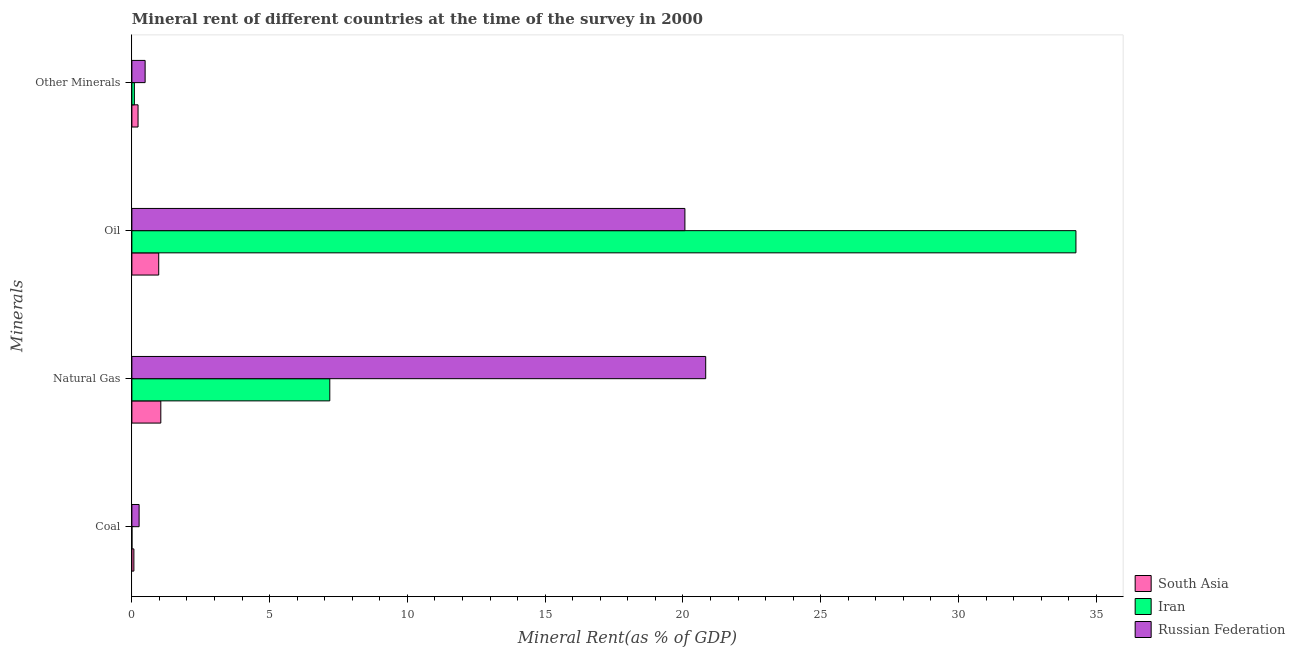How many groups of bars are there?
Your answer should be compact. 4. Are the number of bars per tick equal to the number of legend labels?
Ensure brevity in your answer.  Yes. How many bars are there on the 2nd tick from the bottom?
Offer a terse response. 3. What is the label of the 4th group of bars from the top?
Your answer should be very brief. Coal. What is the natural gas rent in South Asia?
Your answer should be very brief. 1.05. Across all countries, what is the maximum oil rent?
Ensure brevity in your answer.  34.26. Across all countries, what is the minimum natural gas rent?
Your answer should be very brief. 1.05. In which country was the oil rent maximum?
Offer a terse response. Iran. What is the total  rent of other minerals in the graph?
Your response must be concise. 0.8. What is the difference between the oil rent in Iran and that in Russian Federation?
Offer a terse response. 14.19. What is the difference between the oil rent in Iran and the natural gas rent in Russian Federation?
Provide a short and direct response. 13.44. What is the average natural gas rent per country?
Your answer should be compact. 9.69. What is the difference between the natural gas rent and  rent of other minerals in Russian Federation?
Keep it short and to the point. 20.34. In how many countries, is the natural gas rent greater than 25 %?
Offer a terse response. 0. What is the ratio of the natural gas rent in Russian Federation to that in South Asia?
Give a very brief answer. 19.83. Is the oil rent in Iran less than that in South Asia?
Ensure brevity in your answer.  No. What is the difference between the highest and the second highest natural gas rent?
Give a very brief answer. 13.64. What is the difference between the highest and the lowest oil rent?
Provide a succinct answer. 33.29. Is the sum of the  rent of other minerals in South Asia and Russian Federation greater than the maximum coal rent across all countries?
Provide a succinct answer. Yes. Is it the case that in every country, the sum of the coal rent and oil rent is greater than the sum of natural gas rent and  rent of other minerals?
Provide a short and direct response. Yes. What does the 1st bar from the top in Oil represents?
Your answer should be compact. Russian Federation. What does the 3rd bar from the bottom in Natural Gas represents?
Your answer should be compact. Russian Federation. Is it the case that in every country, the sum of the coal rent and natural gas rent is greater than the oil rent?
Provide a short and direct response. No. How many bars are there?
Offer a very short reply. 12. Are all the bars in the graph horizontal?
Offer a terse response. Yes. What is the difference between two consecutive major ticks on the X-axis?
Your answer should be very brief. 5. Are the values on the major ticks of X-axis written in scientific E-notation?
Provide a short and direct response. No. Does the graph contain any zero values?
Keep it short and to the point. No. Does the graph contain grids?
Your answer should be very brief. No. How many legend labels are there?
Keep it short and to the point. 3. What is the title of the graph?
Your answer should be compact. Mineral rent of different countries at the time of the survey in 2000. Does "St. Vincent and the Grenadines" appear as one of the legend labels in the graph?
Make the answer very short. No. What is the label or title of the X-axis?
Make the answer very short. Mineral Rent(as % of GDP). What is the label or title of the Y-axis?
Give a very brief answer. Minerals. What is the Mineral Rent(as % of GDP) of South Asia in Coal?
Offer a terse response. 0.07. What is the Mineral Rent(as % of GDP) of Iran in Coal?
Offer a very short reply. 0. What is the Mineral Rent(as % of GDP) of Russian Federation in Coal?
Provide a short and direct response. 0.26. What is the Mineral Rent(as % of GDP) in South Asia in Natural Gas?
Offer a terse response. 1.05. What is the Mineral Rent(as % of GDP) in Iran in Natural Gas?
Make the answer very short. 7.18. What is the Mineral Rent(as % of GDP) in Russian Federation in Natural Gas?
Provide a succinct answer. 20.83. What is the Mineral Rent(as % of GDP) of South Asia in Oil?
Offer a very short reply. 0.97. What is the Mineral Rent(as % of GDP) of Iran in Oil?
Give a very brief answer. 34.26. What is the Mineral Rent(as % of GDP) in Russian Federation in Oil?
Keep it short and to the point. 20.07. What is the Mineral Rent(as % of GDP) of South Asia in Other Minerals?
Your answer should be very brief. 0.22. What is the Mineral Rent(as % of GDP) of Iran in Other Minerals?
Offer a very short reply. 0.09. What is the Mineral Rent(as % of GDP) of Russian Federation in Other Minerals?
Ensure brevity in your answer.  0.48. Across all Minerals, what is the maximum Mineral Rent(as % of GDP) of South Asia?
Provide a short and direct response. 1.05. Across all Minerals, what is the maximum Mineral Rent(as % of GDP) of Iran?
Make the answer very short. 34.26. Across all Minerals, what is the maximum Mineral Rent(as % of GDP) of Russian Federation?
Offer a very short reply. 20.83. Across all Minerals, what is the minimum Mineral Rent(as % of GDP) of South Asia?
Keep it short and to the point. 0.07. Across all Minerals, what is the minimum Mineral Rent(as % of GDP) of Iran?
Offer a terse response. 0. Across all Minerals, what is the minimum Mineral Rent(as % of GDP) in Russian Federation?
Offer a very short reply. 0.26. What is the total Mineral Rent(as % of GDP) in South Asia in the graph?
Make the answer very short. 2.32. What is the total Mineral Rent(as % of GDP) in Iran in the graph?
Make the answer very short. 41.54. What is the total Mineral Rent(as % of GDP) of Russian Federation in the graph?
Your response must be concise. 41.64. What is the difference between the Mineral Rent(as % of GDP) of South Asia in Coal and that in Natural Gas?
Give a very brief answer. -0.98. What is the difference between the Mineral Rent(as % of GDP) in Iran in Coal and that in Natural Gas?
Provide a succinct answer. -7.18. What is the difference between the Mineral Rent(as % of GDP) in Russian Federation in Coal and that in Natural Gas?
Offer a terse response. -20.56. What is the difference between the Mineral Rent(as % of GDP) of South Asia in Coal and that in Oil?
Your answer should be compact. -0.9. What is the difference between the Mineral Rent(as % of GDP) of Iran in Coal and that in Oil?
Make the answer very short. -34.26. What is the difference between the Mineral Rent(as % of GDP) of Russian Federation in Coal and that in Oil?
Ensure brevity in your answer.  -19.81. What is the difference between the Mineral Rent(as % of GDP) of South Asia in Coal and that in Other Minerals?
Your response must be concise. -0.15. What is the difference between the Mineral Rent(as % of GDP) in Iran in Coal and that in Other Minerals?
Make the answer very short. -0.09. What is the difference between the Mineral Rent(as % of GDP) of Russian Federation in Coal and that in Other Minerals?
Give a very brief answer. -0.22. What is the difference between the Mineral Rent(as % of GDP) in South Asia in Natural Gas and that in Oil?
Your response must be concise. 0.08. What is the difference between the Mineral Rent(as % of GDP) of Iran in Natural Gas and that in Oil?
Offer a terse response. -27.08. What is the difference between the Mineral Rent(as % of GDP) in Russian Federation in Natural Gas and that in Oil?
Your answer should be compact. 0.75. What is the difference between the Mineral Rent(as % of GDP) in South Asia in Natural Gas and that in Other Minerals?
Your answer should be very brief. 0.83. What is the difference between the Mineral Rent(as % of GDP) of Iran in Natural Gas and that in Other Minerals?
Offer a very short reply. 7.09. What is the difference between the Mineral Rent(as % of GDP) of Russian Federation in Natural Gas and that in Other Minerals?
Offer a terse response. 20.34. What is the difference between the Mineral Rent(as % of GDP) in South Asia in Oil and that in Other Minerals?
Offer a very short reply. 0.75. What is the difference between the Mineral Rent(as % of GDP) of Iran in Oil and that in Other Minerals?
Your response must be concise. 34.17. What is the difference between the Mineral Rent(as % of GDP) of Russian Federation in Oil and that in Other Minerals?
Provide a succinct answer. 19.59. What is the difference between the Mineral Rent(as % of GDP) of South Asia in Coal and the Mineral Rent(as % of GDP) of Iran in Natural Gas?
Your answer should be compact. -7.11. What is the difference between the Mineral Rent(as % of GDP) of South Asia in Coal and the Mineral Rent(as % of GDP) of Russian Federation in Natural Gas?
Offer a terse response. -20.75. What is the difference between the Mineral Rent(as % of GDP) of Iran in Coal and the Mineral Rent(as % of GDP) of Russian Federation in Natural Gas?
Provide a short and direct response. -20.82. What is the difference between the Mineral Rent(as % of GDP) of South Asia in Coal and the Mineral Rent(as % of GDP) of Iran in Oil?
Provide a succinct answer. -34.19. What is the difference between the Mineral Rent(as % of GDP) of South Asia in Coal and the Mineral Rent(as % of GDP) of Russian Federation in Oil?
Keep it short and to the point. -20. What is the difference between the Mineral Rent(as % of GDP) in Iran in Coal and the Mineral Rent(as % of GDP) in Russian Federation in Oil?
Provide a succinct answer. -20.07. What is the difference between the Mineral Rent(as % of GDP) of South Asia in Coal and the Mineral Rent(as % of GDP) of Iran in Other Minerals?
Ensure brevity in your answer.  -0.02. What is the difference between the Mineral Rent(as % of GDP) in South Asia in Coal and the Mineral Rent(as % of GDP) in Russian Federation in Other Minerals?
Offer a very short reply. -0.41. What is the difference between the Mineral Rent(as % of GDP) of Iran in Coal and the Mineral Rent(as % of GDP) of Russian Federation in Other Minerals?
Keep it short and to the point. -0.48. What is the difference between the Mineral Rent(as % of GDP) of South Asia in Natural Gas and the Mineral Rent(as % of GDP) of Iran in Oil?
Ensure brevity in your answer.  -33.21. What is the difference between the Mineral Rent(as % of GDP) of South Asia in Natural Gas and the Mineral Rent(as % of GDP) of Russian Federation in Oil?
Make the answer very short. -19.02. What is the difference between the Mineral Rent(as % of GDP) in Iran in Natural Gas and the Mineral Rent(as % of GDP) in Russian Federation in Oil?
Provide a succinct answer. -12.89. What is the difference between the Mineral Rent(as % of GDP) in South Asia in Natural Gas and the Mineral Rent(as % of GDP) in Iran in Other Minerals?
Offer a very short reply. 0.96. What is the difference between the Mineral Rent(as % of GDP) of South Asia in Natural Gas and the Mineral Rent(as % of GDP) of Russian Federation in Other Minerals?
Your answer should be very brief. 0.57. What is the difference between the Mineral Rent(as % of GDP) of Iran in Natural Gas and the Mineral Rent(as % of GDP) of Russian Federation in Other Minerals?
Your response must be concise. 6.7. What is the difference between the Mineral Rent(as % of GDP) in South Asia in Oil and the Mineral Rent(as % of GDP) in Iran in Other Minerals?
Provide a short and direct response. 0.88. What is the difference between the Mineral Rent(as % of GDP) in South Asia in Oil and the Mineral Rent(as % of GDP) in Russian Federation in Other Minerals?
Provide a short and direct response. 0.49. What is the difference between the Mineral Rent(as % of GDP) of Iran in Oil and the Mineral Rent(as % of GDP) of Russian Federation in Other Minerals?
Ensure brevity in your answer.  33.78. What is the average Mineral Rent(as % of GDP) of South Asia per Minerals?
Provide a succinct answer. 0.58. What is the average Mineral Rent(as % of GDP) in Iran per Minerals?
Provide a short and direct response. 10.38. What is the average Mineral Rent(as % of GDP) in Russian Federation per Minerals?
Your answer should be very brief. 10.41. What is the difference between the Mineral Rent(as % of GDP) of South Asia and Mineral Rent(as % of GDP) of Iran in Coal?
Your answer should be compact. 0.07. What is the difference between the Mineral Rent(as % of GDP) in South Asia and Mineral Rent(as % of GDP) in Russian Federation in Coal?
Provide a succinct answer. -0.19. What is the difference between the Mineral Rent(as % of GDP) in Iran and Mineral Rent(as % of GDP) in Russian Federation in Coal?
Make the answer very short. -0.26. What is the difference between the Mineral Rent(as % of GDP) in South Asia and Mineral Rent(as % of GDP) in Iran in Natural Gas?
Your answer should be compact. -6.13. What is the difference between the Mineral Rent(as % of GDP) in South Asia and Mineral Rent(as % of GDP) in Russian Federation in Natural Gas?
Ensure brevity in your answer.  -19.78. What is the difference between the Mineral Rent(as % of GDP) of Iran and Mineral Rent(as % of GDP) of Russian Federation in Natural Gas?
Keep it short and to the point. -13.64. What is the difference between the Mineral Rent(as % of GDP) of South Asia and Mineral Rent(as % of GDP) of Iran in Oil?
Make the answer very short. -33.29. What is the difference between the Mineral Rent(as % of GDP) of South Asia and Mineral Rent(as % of GDP) of Russian Federation in Oil?
Keep it short and to the point. -19.1. What is the difference between the Mineral Rent(as % of GDP) in Iran and Mineral Rent(as % of GDP) in Russian Federation in Oil?
Provide a short and direct response. 14.19. What is the difference between the Mineral Rent(as % of GDP) of South Asia and Mineral Rent(as % of GDP) of Iran in Other Minerals?
Offer a very short reply. 0.13. What is the difference between the Mineral Rent(as % of GDP) of South Asia and Mineral Rent(as % of GDP) of Russian Federation in Other Minerals?
Give a very brief answer. -0.26. What is the difference between the Mineral Rent(as % of GDP) in Iran and Mineral Rent(as % of GDP) in Russian Federation in Other Minerals?
Give a very brief answer. -0.39. What is the ratio of the Mineral Rent(as % of GDP) of South Asia in Coal to that in Natural Gas?
Offer a very short reply. 0.07. What is the ratio of the Mineral Rent(as % of GDP) in Russian Federation in Coal to that in Natural Gas?
Your answer should be very brief. 0.01. What is the ratio of the Mineral Rent(as % of GDP) of South Asia in Coal to that in Oil?
Provide a short and direct response. 0.07. What is the ratio of the Mineral Rent(as % of GDP) in Iran in Coal to that in Oil?
Offer a terse response. 0. What is the ratio of the Mineral Rent(as % of GDP) in Russian Federation in Coal to that in Oil?
Keep it short and to the point. 0.01. What is the ratio of the Mineral Rent(as % of GDP) of South Asia in Coal to that in Other Minerals?
Your answer should be very brief. 0.33. What is the ratio of the Mineral Rent(as % of GDP) in Iran in Coal to that in Other Minerals?
Offer a terse response. 0.03. What is the ratio of the Mineral Rent(as % of GDP) in Russian Federation in Coal to that in Other Minerals?
Your answer should be very brief. 0.55. What is the ratio of the Mineral Rent(as % of GDP) of South Asia in Natural Gas to that in Oil?
Provide a short and direct response. 1.08. What is the ratio of the Mineral Rent(as % of GDP) in Iran in Natural Gas to that in Oil?
Ensure brevity in your answer.  0.21. What is the ratio of the Mineral Rent(as % of GDP) in Russian Federation in Natural Gas to that in Oil?
Keep it short and to the point. 1.04. What is the ratio of the Mineral Rent(as % of GDP) of South Asia in Natural Gas to that in Other Minerals?
Make the answer very short. 4.69. What is the ratio of the Mineral Rent(as % of GDP) of Iran in Natural Gas to that in Other Minerals?
Provide a short and direct response. 79.19. What is the ratio of the Mineral Rent(as % of GDP) in Russian Federation in Natural Gas to that in Other Minerals?
Make the answer very short. 43.3. What is the ratio of the Mineral Rent(as % of GDP) of South Asia in Oil to that in Other Minerals?
Ensure brevity in your answer.  4.35. What is the ratio of the Mineral Rent(as % of GDP) in Iran in Oil to that in Other Minerals?
Your answer should be compact. 377.72. What is the ratio of the Mineral Rent(as % of GDP) in Russian Federation in Oil to that in Other Minerals?
Your answer should be very brief. 41.73. What is the difference between the highest and the second highest Mineral Rent(as % of GDP) in South Asia?
Keep it short and to the point. 0.08. What is the difference between the highest and the second highest Mineral Rent(as % of GDP) in Iran?
Offer a terse response. 27.08. What is the difference between the highest and the second highest Mineral Rent(as % of GDP) of Russian Federation?
Provide a short and direct response. 0.75. What is the difference between the highest and the lowest Mineral Rent(as % of GDP) in South Asia?
Offer a terse response. 0.98. What is the difference between the highest and the lowest Mineral Rent(as % of GDP) of Iran?
Ensure brevity in your answer.  34.26. What is the difference between the highest and the lowest Mineral Rent(as % of GDP) of Russian Federation?
Offer a very short reply. 20.56. 